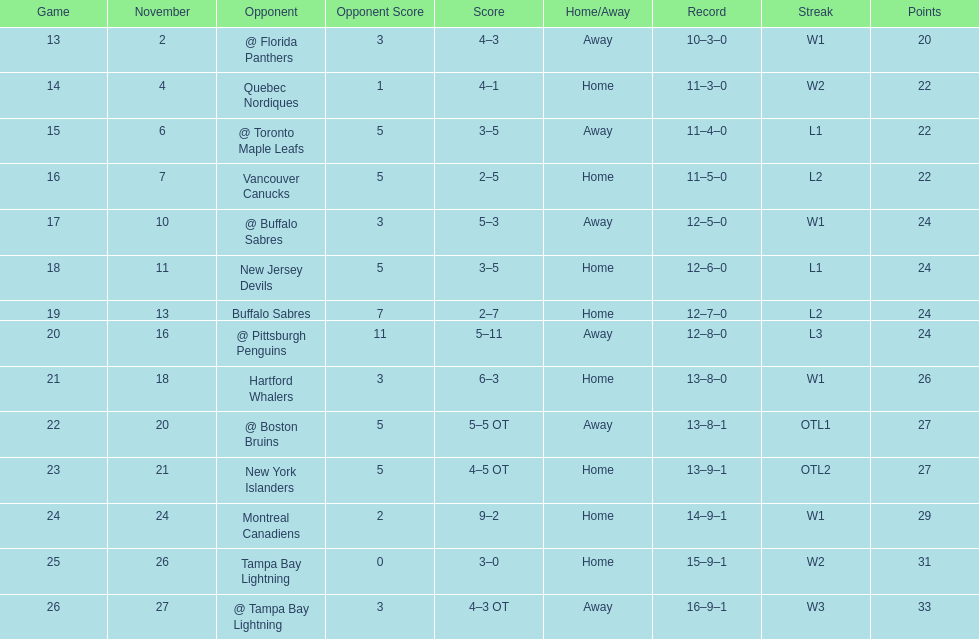What was the number of wins the philadelphia flyers had? 35. 